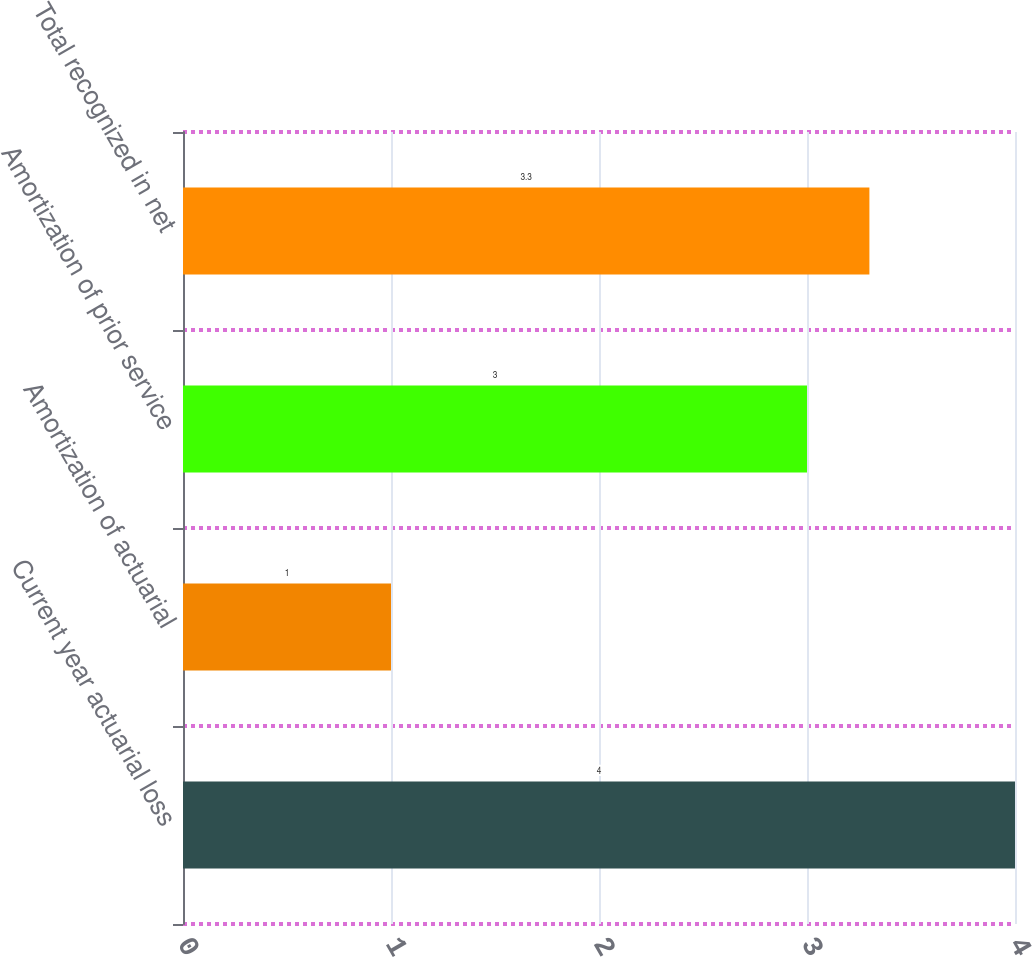<chart> <loc_0><loc_0><loc_500><loc_500><bar_chart><fcel>Current year actuarial loss<fcel>Amortization of actuarial<fcel>Amortization of prior service<fcel>Total recognized in net<nl><fcel>4<fcel>1<fcel>3<fcel>3.3<nl></chart> 